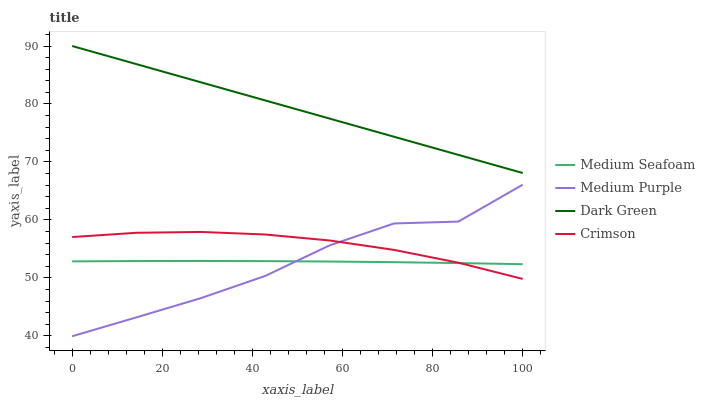Does Medium Purple have the minimum area under the curve?
Answer yes or no. Yes. Does Dark Green have the maximum area under the curve?
Answer yes or no. Yes. Does Crimson have the minimum area under the curve?
Answer yes or no. No. Does Crimson have the maximum area under the curve?
Answer yes or no. No. Is Dark Green the smoothest?
Answer yes or no. Yes. Is Medium Purple the roughest?
Answer yes or no. Yes. Is Crimson the smoothest?
Answer yes or no. No. Is Crimson the roughest?
Answer yes or no. No. Does Medium Purple have the lowest value?
Answer yes or no. Yes. Does Crimson have the lowest value?
Answer yes or no. No. Does Dark Green have the highest value?
Answer yes or no. Yes. Does Crimson have the highest value?
Answer yes or no. No. Is Crimson less than Dark Green?
Answer yes or no. Yes. Is Dark Green greater than Medium Seafoam?
Answer yes or no. Yes. Does Crimson intersect Medium Seafoam?
Answer yes or no. Yes. Is Crimson less than Medium Seafoam?
Answer yes or no. No. Is Crimson greater than Medium Seafoam?
Answer yes or no. No. Does Crimson intersect Dark Green?
Answer yes or no. No. 